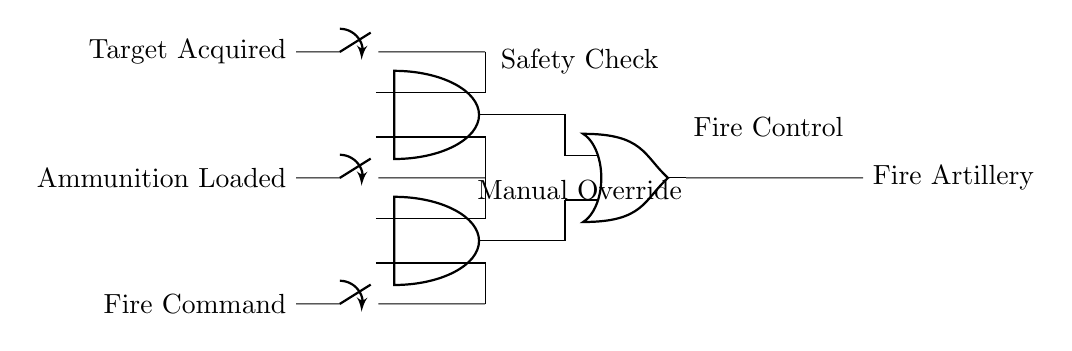What components are used in this circuit? The circuit contains three switches, two AND gates, and one OR gate. These components are indicated in the diagram as they are drawn in specific symbols.
Answer: three switches, two AND gates, one OR gate What is the function of the AND gates in this circuit? The AND gates require both of their inputs to be true (active) in order to produce a true output. This means that for the firing sequence to be initiated, both required conditions need to be satisfied.
Answer: Safety Check and Manual Override How many input conditions are needed to fire the artillery? The circuit specifies three distinct input conditions: Target Acquired, Ammunition Loaded, and Fire Command, but only one of the AND gate outputs needs to be activated through either of the AND gates to trigger the OR gate.
Answer: two What happens if only the Fire Command is active? If only the Fire Command switch is active, it will not be enough to activate either AND gate. Both AND gates need at least two inputs active to generate a true output, so the artillery will not fire.
Answer: artillery will not fire What is the output of the OR gate when both AND gates output true? If both AND gates output true, the OR gate will also output true since an OR gate outputs true if any of its inputs are true. Thus, in this firing sequence, the artillery will fire.
Answer: Fire Artillery What are the roles of the switches in this circuit? The switches serve as input controls to signify the necessary conditions for artillery firing. Each switch symbolizes a condition that must be met to proceed with the operation, making them critical for the logic in the firing sequence.
Answer: input controls Which condition is represented by the switch labeled "Ammunition Loaded"? The switch labeled "Ammunition Loaded" signifies that the artillery has been prepared with ammunition, which is necessary for firing. This condition is essential for activating the respective AND gate in the circuit.
Answer: Ammunition Loaded 